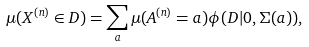<formula> <loc_0><loc_0><loc_500><loc_500>\mu ( X ^ { ( n ) } \in D ) = \sum _ { a } \mu ( A ^ { ( n ) } = a ) \phi ( D | 0 , \Sigma ( a ) ) ,</formula> 